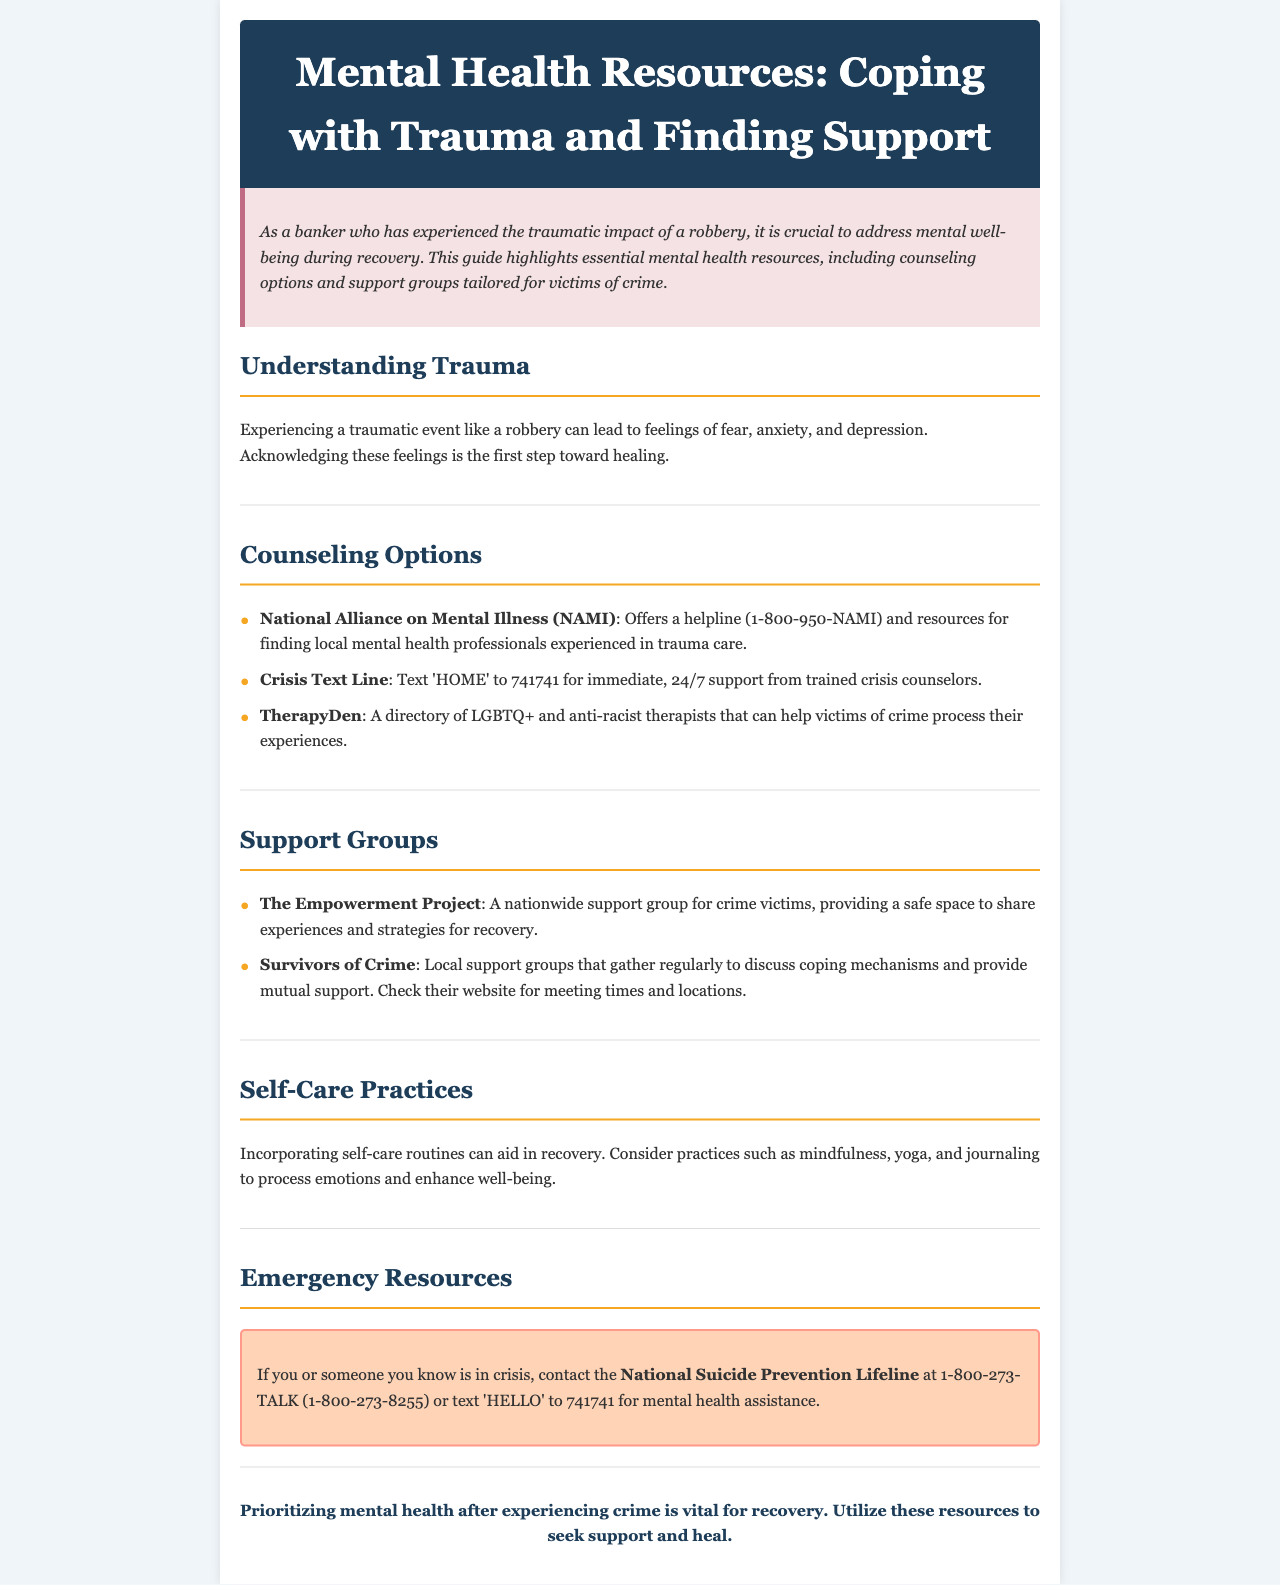What is the helpline number for the National Alliance on Mental Illness? The helpline number is mentioned in the Counseling Options section of the document.
Answer: 1-800-950-NAMI What text should you send to access the Crisis Text Line? The document specifies the text that needs to be sent for immediate support.
Answer: HOME What is the main focus of The Empowerment Project? This information is found in the Support Groups section, detailing the purpose of the support group.
Answer: Support for crime victims Name one self-care practice suggested in the document. The document lists practices in the Self-Care Practices section that aid in recovery.
Answer: Mindfulness What emergency resource is provided for those in crisis? The document has an entire section dedicated to emergency resources, including an important contact.
Answer: National Suicide Prevention Lifeline 